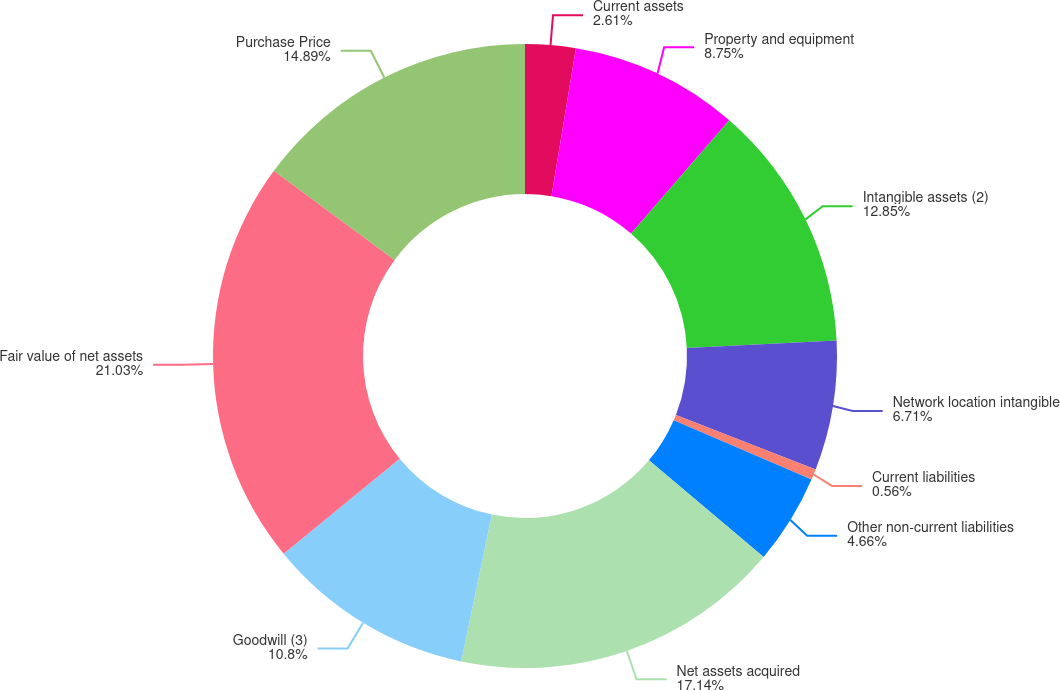Convert chart. <chart><loc_0><loc_0><loc_500><loc_500><pie_chart><fcel>Current assets<fcel>Property and equipment<fcel>Intangible assets (2)<fcel>Network location intangible<fcel>Current liabilities<fcel>Other non-current liabilities<fcel>Net assets acquired<fcel>Goodwill (3)<fcel>Fair value of net assets<fcel>Purchase Price<nl><fcel>2.61%<fcel>8.75%<fcel>12.85%<fcel>6.71%<fcel>0.56%<fcel>4.66%<fcel>17.14%<fcel>10.8%<fcel>21.03%<fcel>14.89%<nl></chart> 